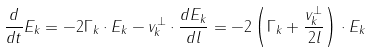Convert formula to latex. <formula><loc_0><loc_0><loc_500><loc_500>\frac { d } { d t } E _ { k } = - 2 \Gamma _ { k } \cdot E _ { k } - v _ { k } ^ { \perp } \cdot \frac { d E _ { k } } { d l } = - 2 \left ( \Gamma _ { k } + \frac { v _ { k } ^ { \perp } } { 2 l } \right ) \cdot E _ { k }</formula> 